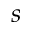Convert formula to latex. <formula><loc_0><loc_0><loc_500><loc_500>s</formula> 